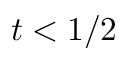Convert formula to latex. <formula><loc_0><loc_0><loc_500><loc_500>t < 1 / 2</formula> 